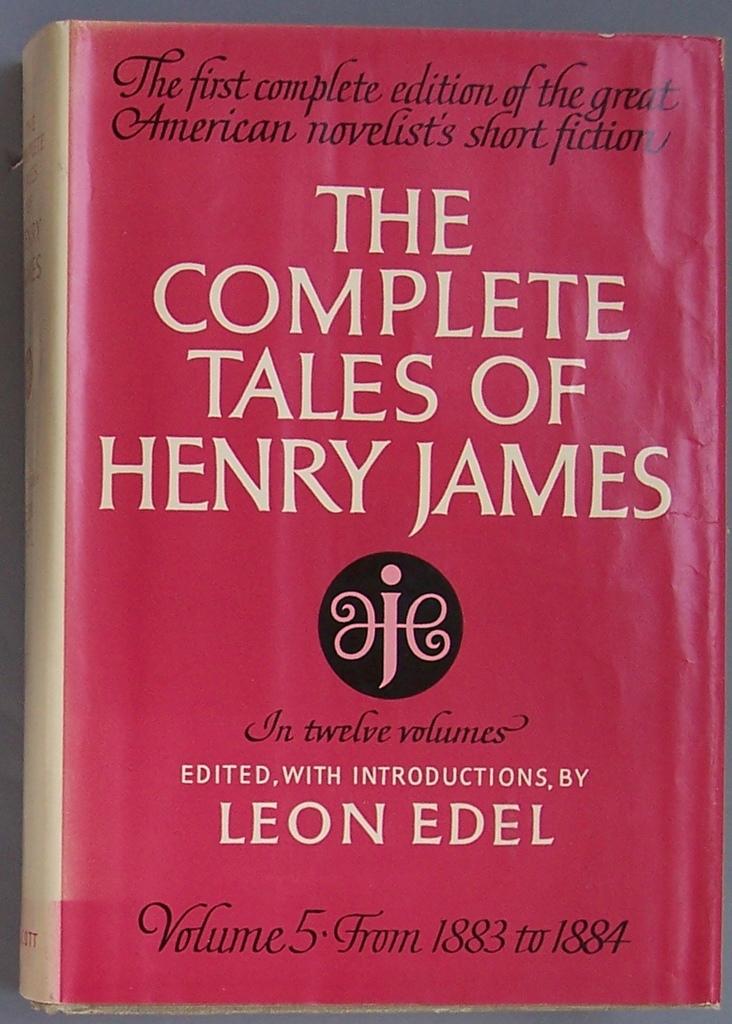Who edited this red book?
Offer a terse response. Leon edel. What volume is this?
Offer a terse response. 5. 